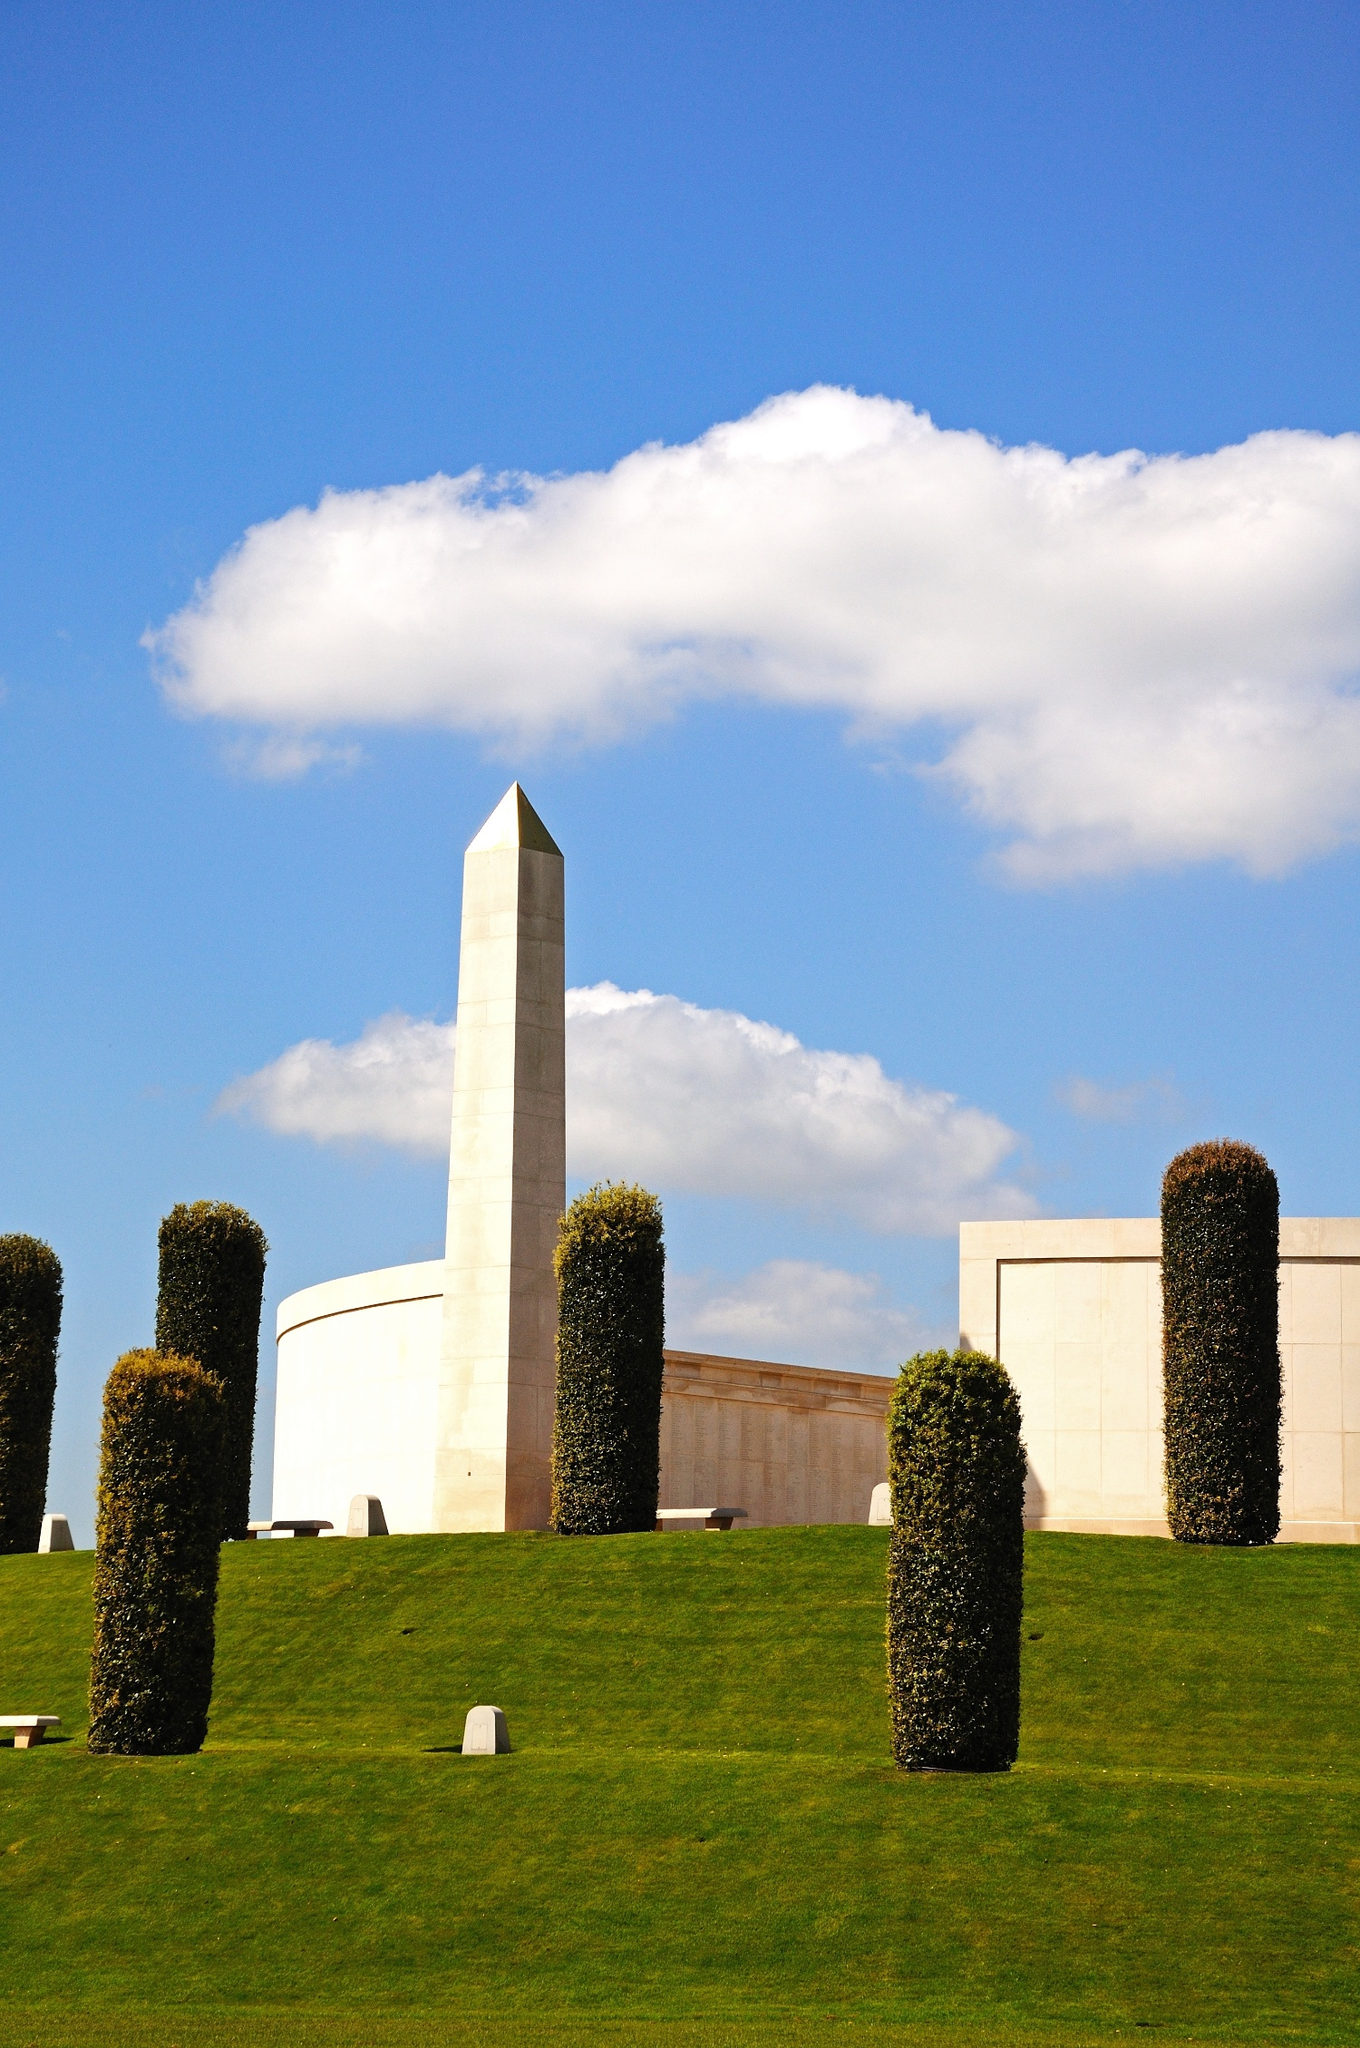What can you tell me about the history of the National Memorial Arboretum? The National Memorial Arboretum in Staffordshire, UK, is a vast landscape of woodlands and gardens dedicated to preserving the memory of those who have served and sacrificed for the nation. Opened in 2001, the 150-acre site is part of The Royal British Legion family of charities. It features over 30,000 trees and numerous memorials to various military units, organizations, and individuals. The arboretum not only serves as a place of reflection and remembrance but also acts as an educational resource, hosting events and activities to engage visitors in the history and significance of military service. Are there any notable events held at the National Memorial Arboretum? Yes, the National Memorial Arboretum hosts several significant events throughout the year. Remembrance Sunday and Armistice Day are among the most prominent, drawing large crowds for commemorative services. These events feature parades, wreath-laying ceremonies, and moments of silence to honor the fallen. Other notable events include charity walks, educational workshops, and themed tours that explore the history of various memorials. The arboretum also hosts family-friendly activities and seasonal celebrations, creating a community-focused environment that honors service and sacrifice year-round. Imagine a conversation between a visitor and a gardener at the arboretum. What might they talk about? Visitor: This place is so peaceful. Do you have a favorite part of the arboretum? 
Gardener: It's hard to choose, but I have a soft spot for the Millennium Chapel. It’s not only beautiful but also the first of its kind, dedicated to all who serve. 
Visitor: It’s incredible how well-maintained everything is. How long does it take to tend the gardens? 
Gardener: Oh, it's a year-round job! Each season brings different tasks. We have a wonderful team of volunteers who help keep the arboretum looking its best. 
Visitor: I noticed the variety of trees and plants. Is there a significance to them? 
Gardener: Absolutely. Many of the trees here have been chosen for their symbolic meanings or associations with specific regiments, units, or events. Like the scarlet oaks planted in memory of the Battle of Britain. 